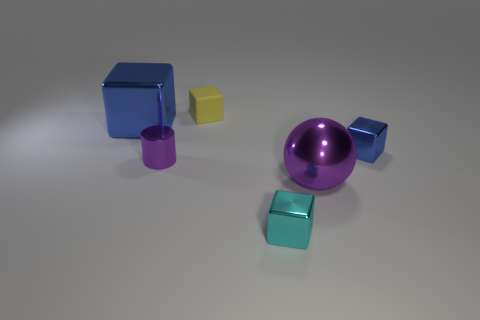The small blue shiny thing has what shape?
Provide a short and direct response. Cube. There is a blue metal object left of the blue metallic cube on the right side of the tiny yellow thing; what is its shape?
Your response must be concise. Cube. What number of other objects are there of the same shape as the cyan metal object?
Keep it short and to the point. 3. What size is the cube in front of the purple metallic object right of the yellow block?
Provide a succinct answer. Small. Are any big red things visible?
Your response must be concise. No. What number of things are in front of the blue object on the right side of the large cube?
Offer a very short reply. 3. What is the shape of the big thing that is behind the small blue metal cube?
Make the answer very short. Cube. What material is the purple thing that is right of the tiny object that is behind the blue object that is behind the small blue thing?
Provide a short and direct response. Metal. What number of other objects are the same size as the metal cylinder?
Your response must be concise. 3. What is the material of the big blue object that is the same shape as the tiny cyan object?
Your response must be concise. Metal. 